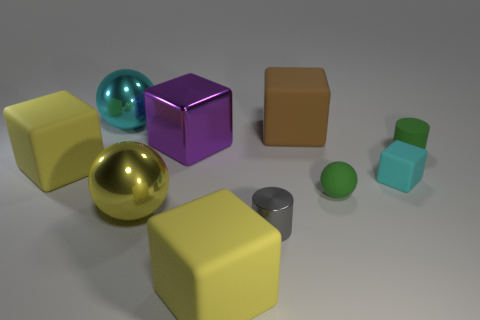Is the material of the cyan block the same as the green ball?
Provide a short and direct response. Yes. How many spheres are either blue rubber things or gray metal objects?
Make the answer very short. 0. The shiny ball that is in front of the big matte block to the left of the cyan shiny sphere is what color?
Offer a very short reply. Yellow. The shiny thing that is the same color as the small rubber cube is what size?
Offer a very short reply. Large. There is a ball that is to the right of the big cube in front of the small cube; how many matte cylinders are left of it?
Ensure brevity in your answer.  0. Does the big object on the left side of the cyan shiny ball have the same shape as the purple object that is to the left of the brown rubber block?
Your answer should be very brief. Yes. What number of things are either green rubber cylinders or tiny brown rubber things?
Make the answer very short. 1. What material is the tiny green thing that is behind the green object that is to the left of the green matte cylinder?
Keep it short and to the point. Rubber. Are there any other small rubber balls that have the same color as the tiny matte ball?
Ensure brevity in your answer.  No. What color is the other metallic sphere that is the same size as the cyan ball?
Offer a terse response. Yellow. 